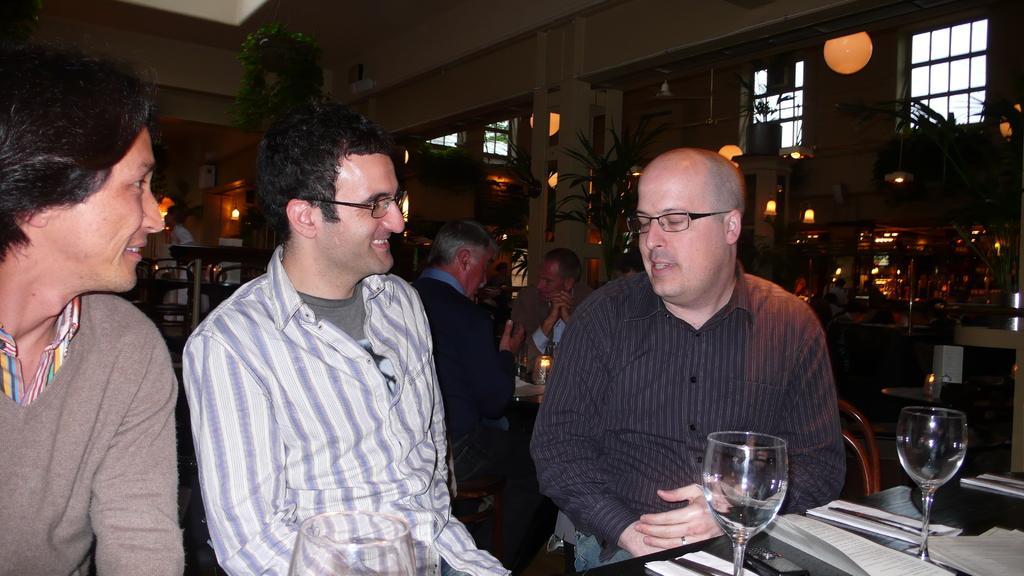Please provide a concise description of this image. In this image we can see a few people, there are tables, chairs, on the tables there are glasses, papers, candle, there are lights, pillars, walls, house plants, also we can see the roof. 